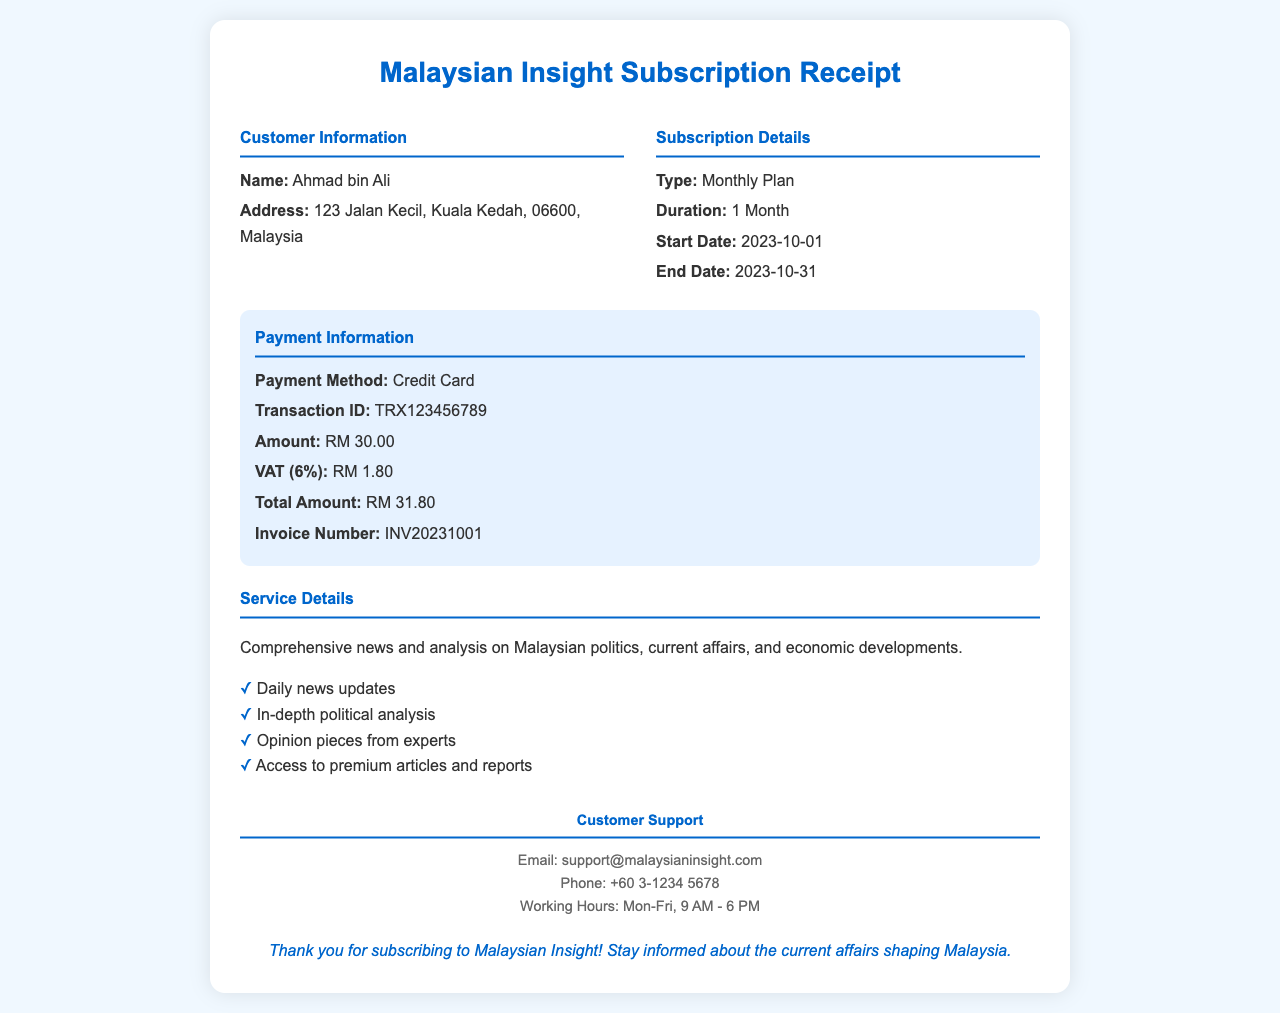What is the customer's name? The customer's name as stated in the document is Ahmad bin Ali.
Answer: Ahmad bin Ali What is the subscription type? The type of subscription is detailed under the Subscription Details section, which specifies Monthly Plan.
Answer: Monthly Plan What is the total amount billed? The total amount is listed in the Payment Information section, which states RM 31.80.
Answer: RM 31.80 When does the subscription start? The start date for the subscription is provided in the Subscription Details, which is 2023-10-01.
Answer: 2023-10-01 How can I contact customer support? Customer support contact information is detailed, including an email and phone number, making it easy to find.
Answer: support@malaysianinsight.com What is the VAT charged? The VAT amount is specifically outlined in the Payment Information, which shows RM 1.80.
Answer: RM 1.80 What is the invoice number? The invoice number is indicated in the Payment Information section, which states INV20231001.
Answer: INV20231001 What duration does the subscription cover? The duration of the subscription is mentioned under Subscription Details, which is 1 Month.
Answer: 1 Month List one feature of the service. The features of the service are enumerated in the Service Details section, providing insights on its offerings.
Answer: Daily news updates 